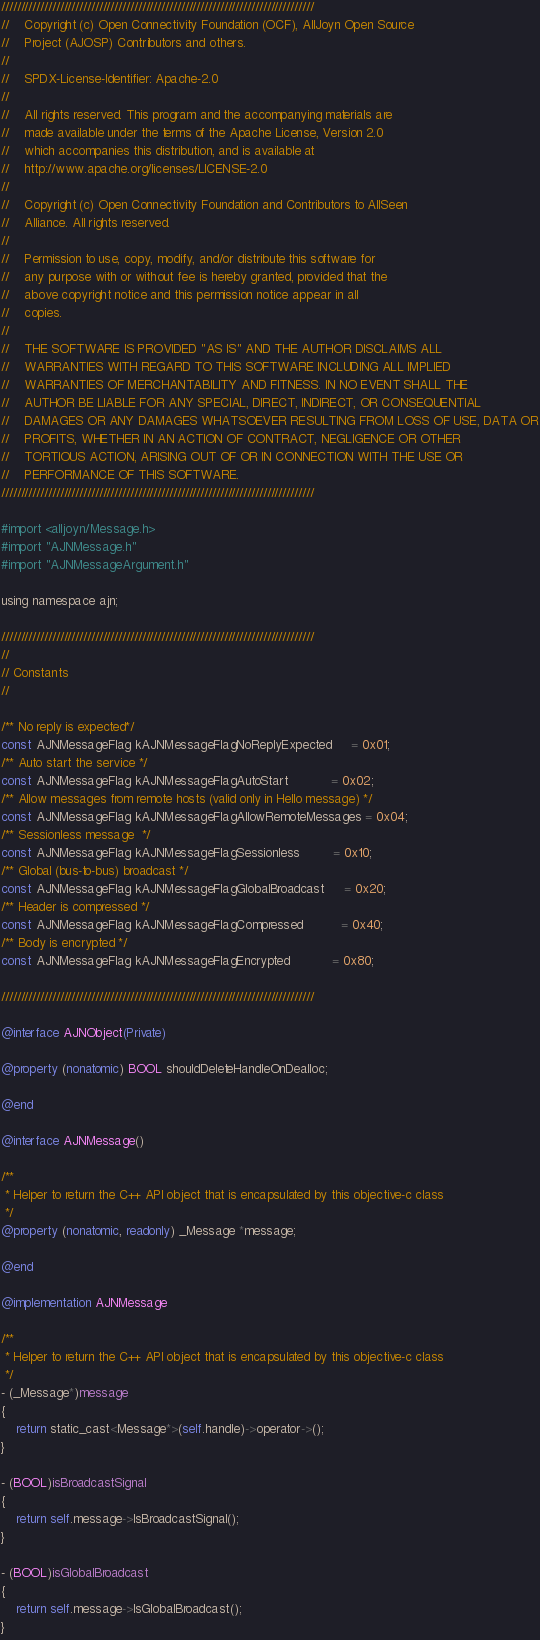Convert code to text. <code><loc_0><loc_0><loc_500><loc_500><_ObjectiveC_>////////////////////////////////////////////////////////////////////////////////
//    Copyright (c) Open Connectivity Foundation (OCF), AllJoyn Open Source
//    Project (AJOSP) Contributors and others.
//
//    SPDX-License-Identifier: Apache-2.0
//
//    All rights reserved. This program and the accompanying materials are
//    made available under the terms of the Apache License, Version 2.0
//    which accompanies this distribution, and is available at
//    http://www.apache.org/licenses/LICENSE-2.0
//
//    Copyright (c) Open Connectivity Foundation and Contributors to AllSeen
//    Alliance. All rights reserved.
//
//    Permission to use, copy, modify, and/or distribute this software for
//    any purpose with or without fee is hereby granted, provided that the
//    above copyright notice and this permission notice appear in all
//    copies.
//
//    THE SOFTWARE IS PROVIDED "AS IS" AND THE AUTHOR DISCLAIMS ALL
//    WARRANTIES WITH REGARD TO THIS SOFTWARE INCLUDING ALL IMPLIED
//    WARRANTIES OF MERCHANTABILITY AND FITNESS. IN NO EVENT SHALL THE
//    AUTHOR BE LIABLE FOR ANY SPECIAL, DIRECT, INDIRECT, OR CONSEQUENTIAL
//    DAMAGES OR ANY DAMAGES WHATSOEVER RESULTING FROM LOSS OF USE, DATA OR
//    PROFITS, WHETHER IN AN ACTION OF CONTRACT, NEGLIGENCE OR OTHER
//    TORTIOUS ACTION, ARISING OUT OF OR IN CONNECTION WITH THE USE OR
//    PERFORMANCE OF THIS SOFTWARE.
////////////////////////////////////////////////////////////////////////////////

#import <alljoyn/Message.h>
#import "AJNMessage.h"
#import "AJNMessageArgument.h"

using namespace ajn;

////////////////////////////////////////////////////////////////////////////////
//
// Constants
//

/** No reply is expected*/
const AJNMessageFlag kAJNMessageFlagNoReplyExpected     = 0x01;
/** Auto start the service */
const AJNMessageFlag kAJNMessageFlagAutoStart           = 0x02;
/** Allow messages from remote hosts (valid only in Hello message) */
const AJNMessageFlag kAJNMessageFlagAllowRemoteMessages = 0x04;
/** Sessionless message  */
const AJNMessageFlag kAJNMessageFlagSessionless         = 0x10;
/** Global (bus-to-bus) broadcast */
const AJNMessageFlag kAJNMessageFlagGlobalBroadcast     = 0x20;
/** Header is compressed */
const AJNMessageFlag kAJNMessageFlagCompressed          = 0x40;
/** Body is encrypted */
const AJNMessageFlag kAJNMessageFlagEncrypted           = 0x80;

////////////////////////////////////////////////////////////////////////////////

@interface AJNObject(Private)

@property (nonatomic) BOOL shouldDeleteHandleOnDealloc;

@end

@interface AJNMessage()

/**
 * Helper to return the C++ API object that is encapsulated by this objective-c class
 */
@property (nonatomic, readonly) _Message *message;

@end

@implementation AJNMessage

/**
 * Helper to return the C++ API object that is encapsulated by this objective-c class
 */
- (_Message*)message
{
    return static_cast<Message*>(self.handle)->operator->();
}

- (BOOL)isBroadcastSignal
{
    return self.message->IsBroadcastSignal();
}

- (BOOL)isGlobalBroadcast
{
    return self.message->IsGlobalBroadcast();
}
</code> 